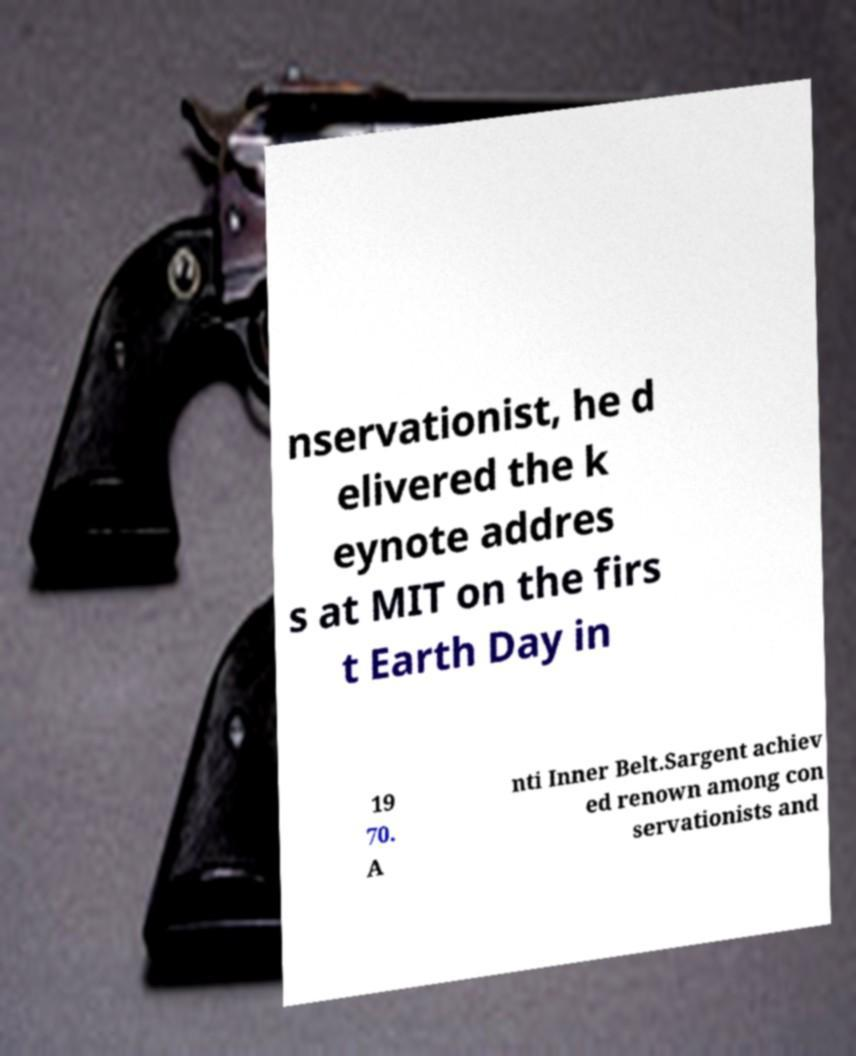I need the written content from this picture converted into text. Can you do that? nservationist, he d elivered the k eynote addres s at MIT on the firs t Earth Day in 19 70. A nti Inner Belt.Sargent achiev ed renown among con servationists and 